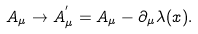<formula> <loc_0><loc_0><loc_500><loc_500>A _ { \mu } \rightarrow A ^ { ^ { \prime } } _ { \mu } = A _ { \mu } - \partial _ { \mu } \lambda ( x ) .</formula> 